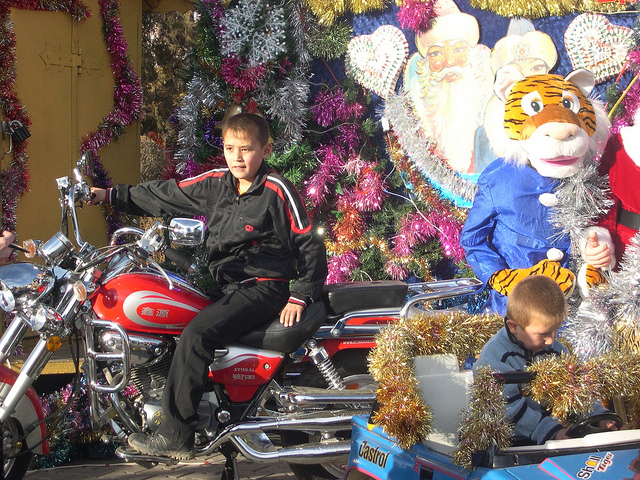<image>Where is the yellow horn? It is unknown where the yellow horn is located. It is not shown in the image. Where is the yellow horn? The location of the yellow horn is unknown. It is not shown in the image. 